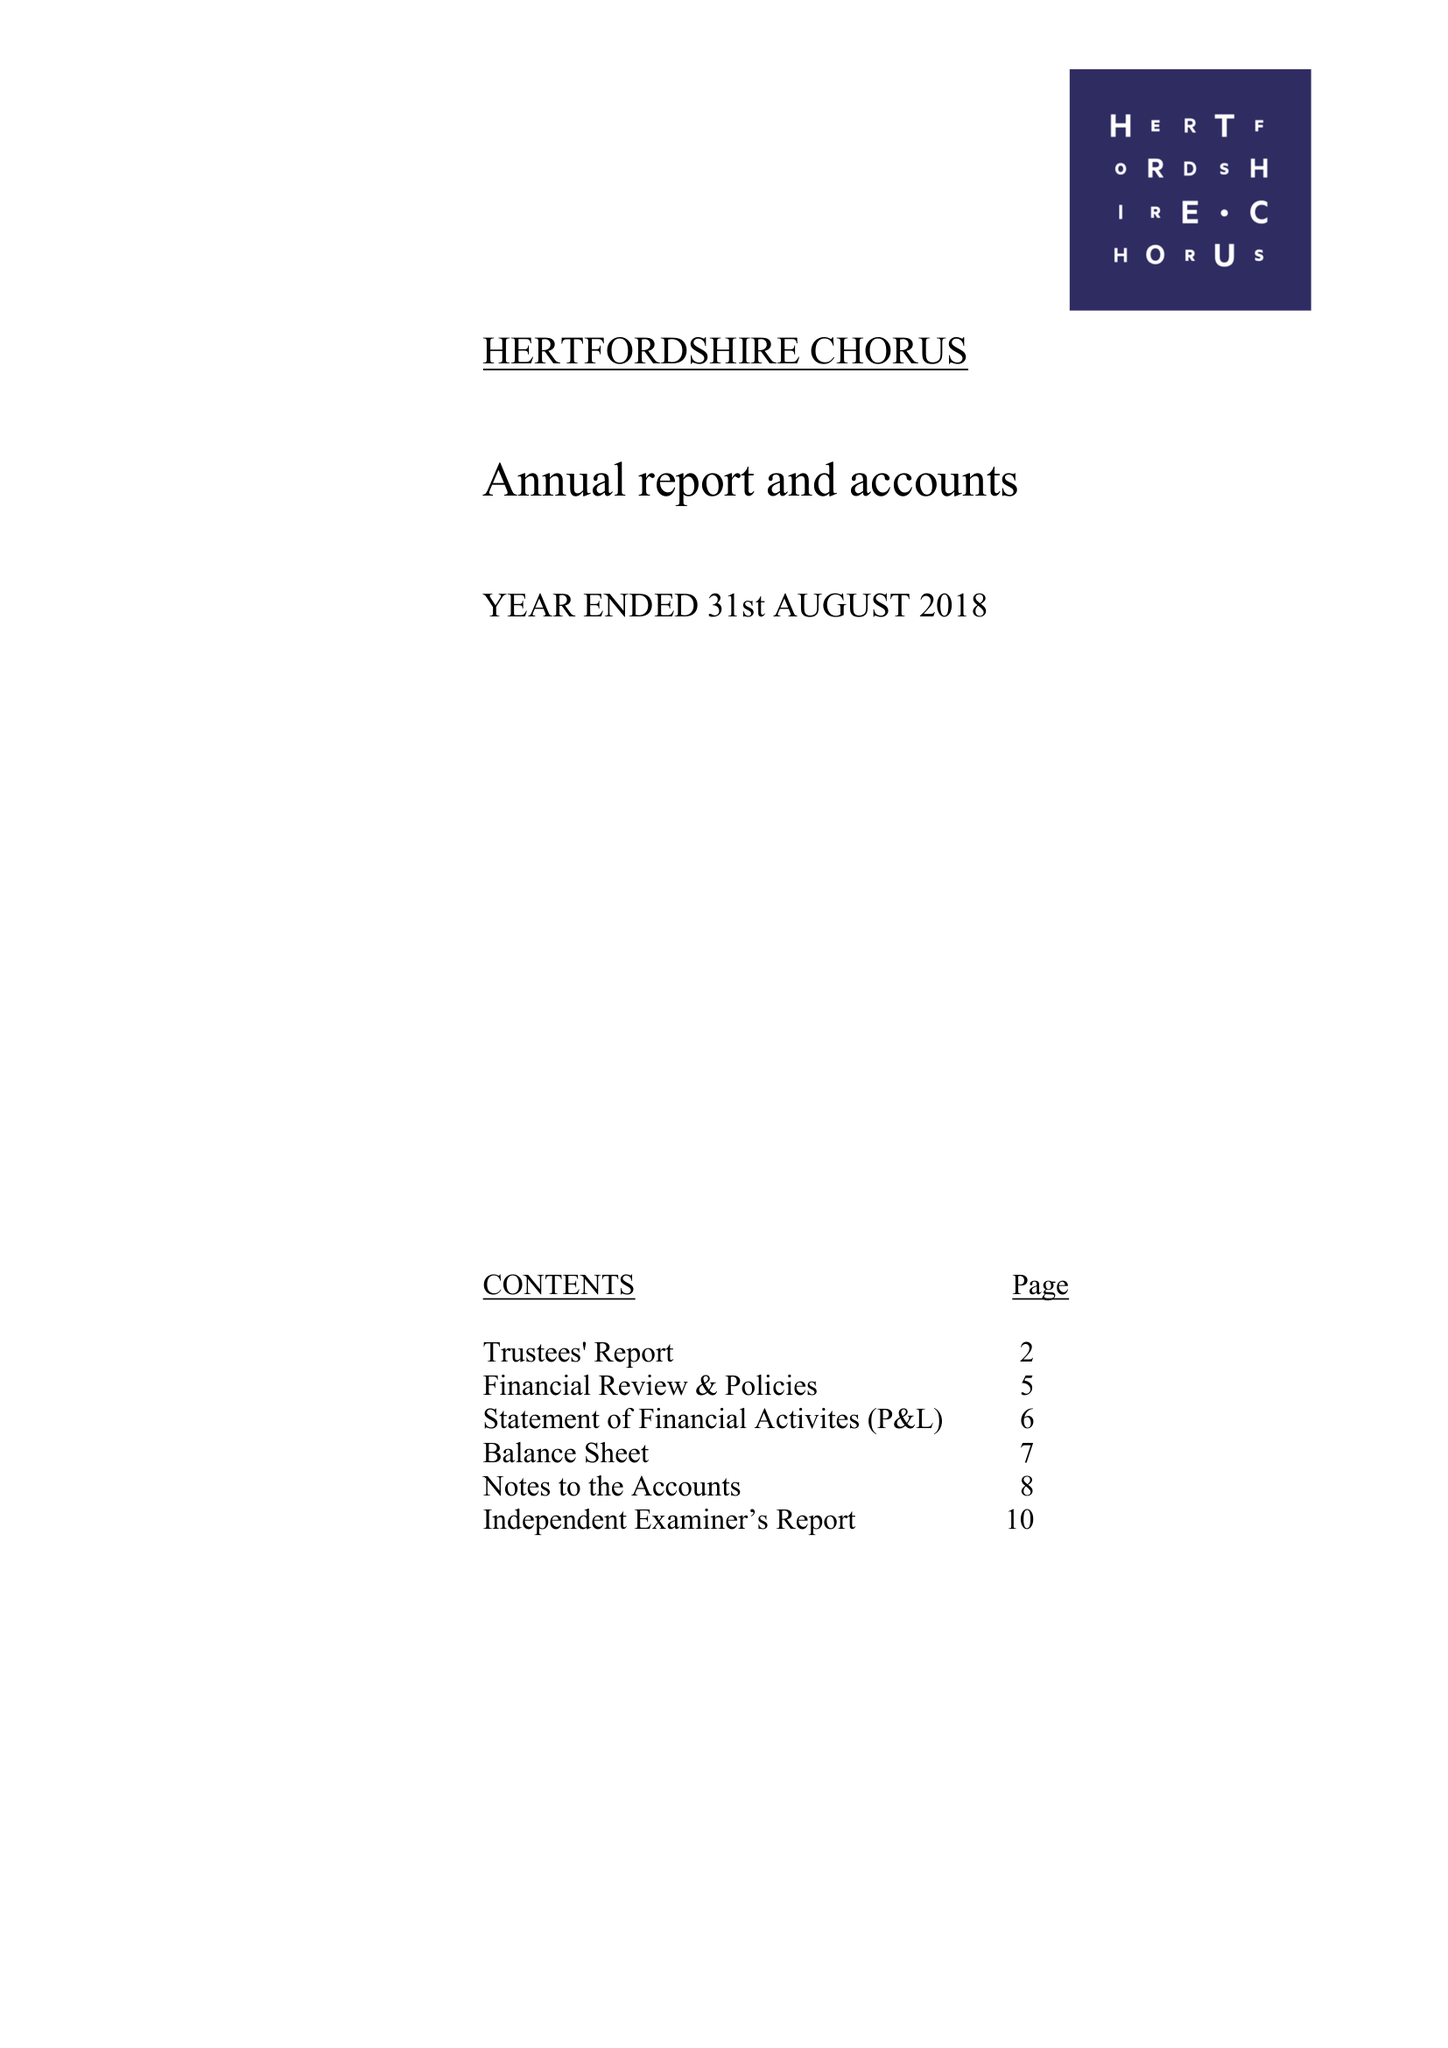What is the value for the report_date?
Answer the question using a single word or phrase. 2018-08-31 